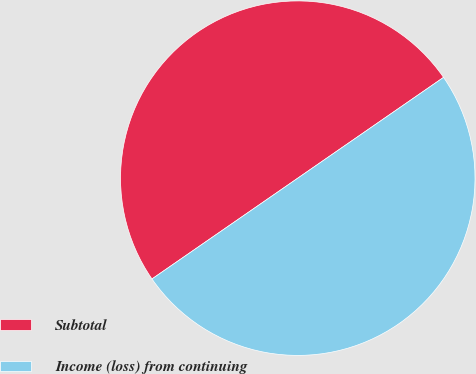Convert chart to OTSL. <chart><loc_0><loc_0><loc_500><loc_500><pie_chart><fcel>Subtotal<fcel>Income (loss) from continuing<nl><fcel>50.0%<fcel>50.0%<nl></chart> 